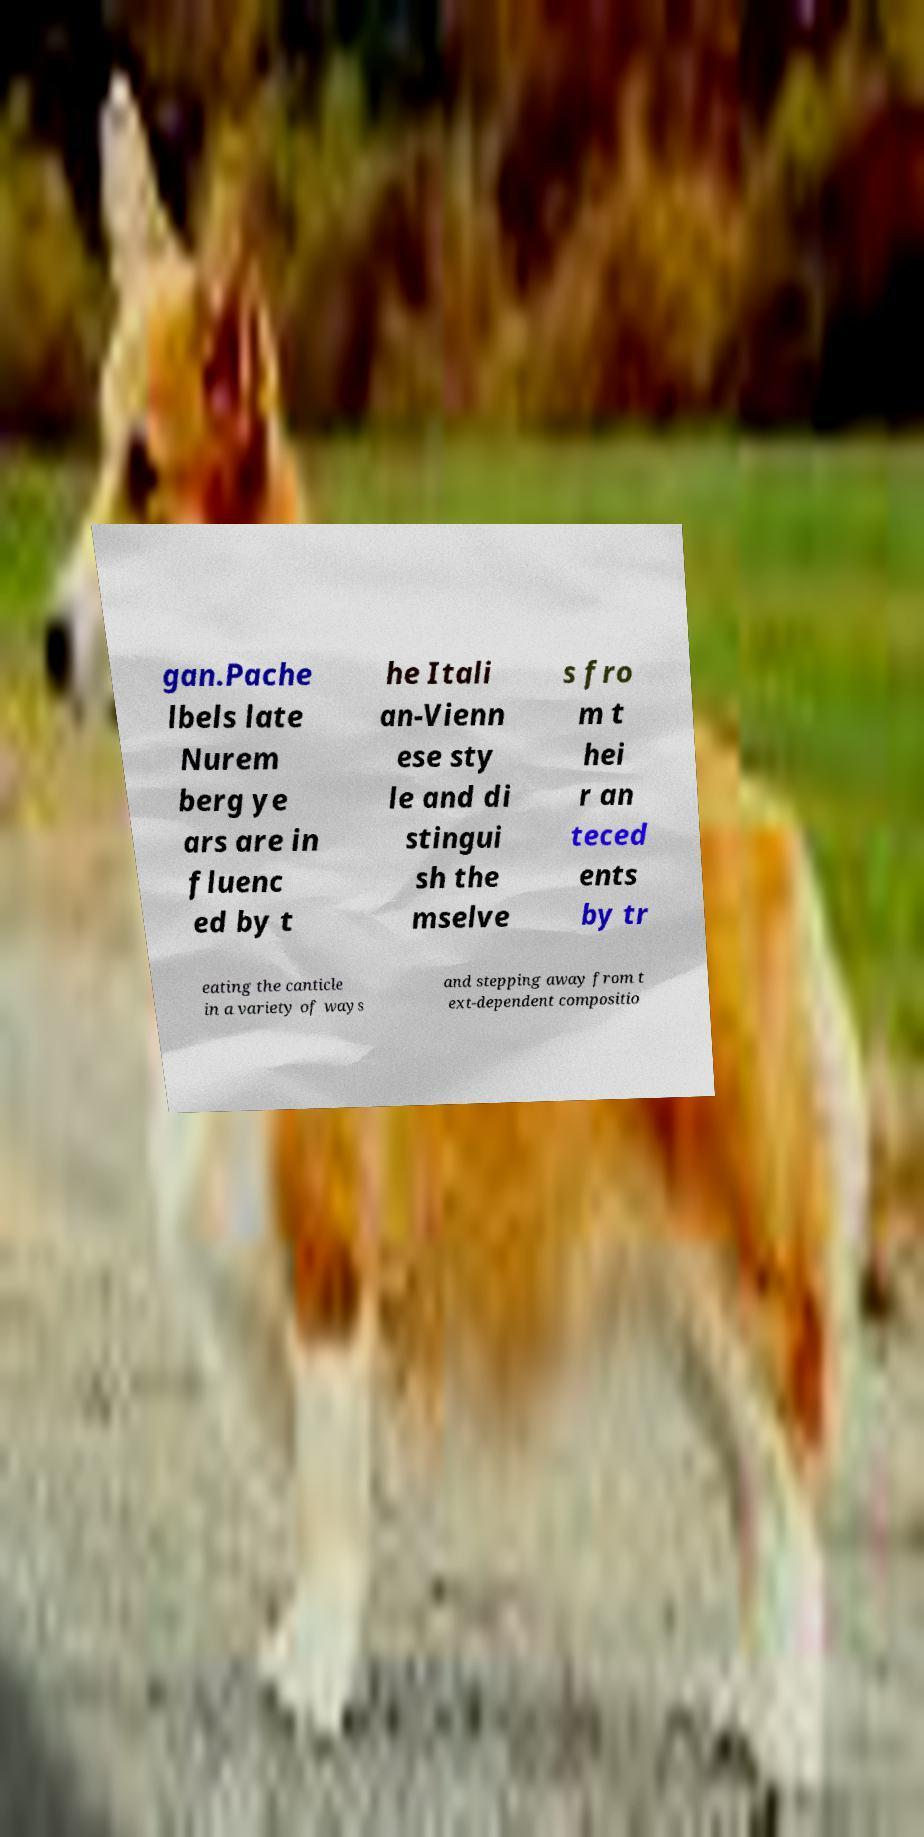There's text embedded in this image that I need extracted. Can you transcribe it verbatim? gan.Pache lbels late Nurem berg ye ars are in fluenc ed by t he Itali an-Vienn ese sty le and di stingui sh the mselve s fro m t hei r an teced ents by tr eating the canticle in a variety of ways and stepping away from t ext-dependent compositio 